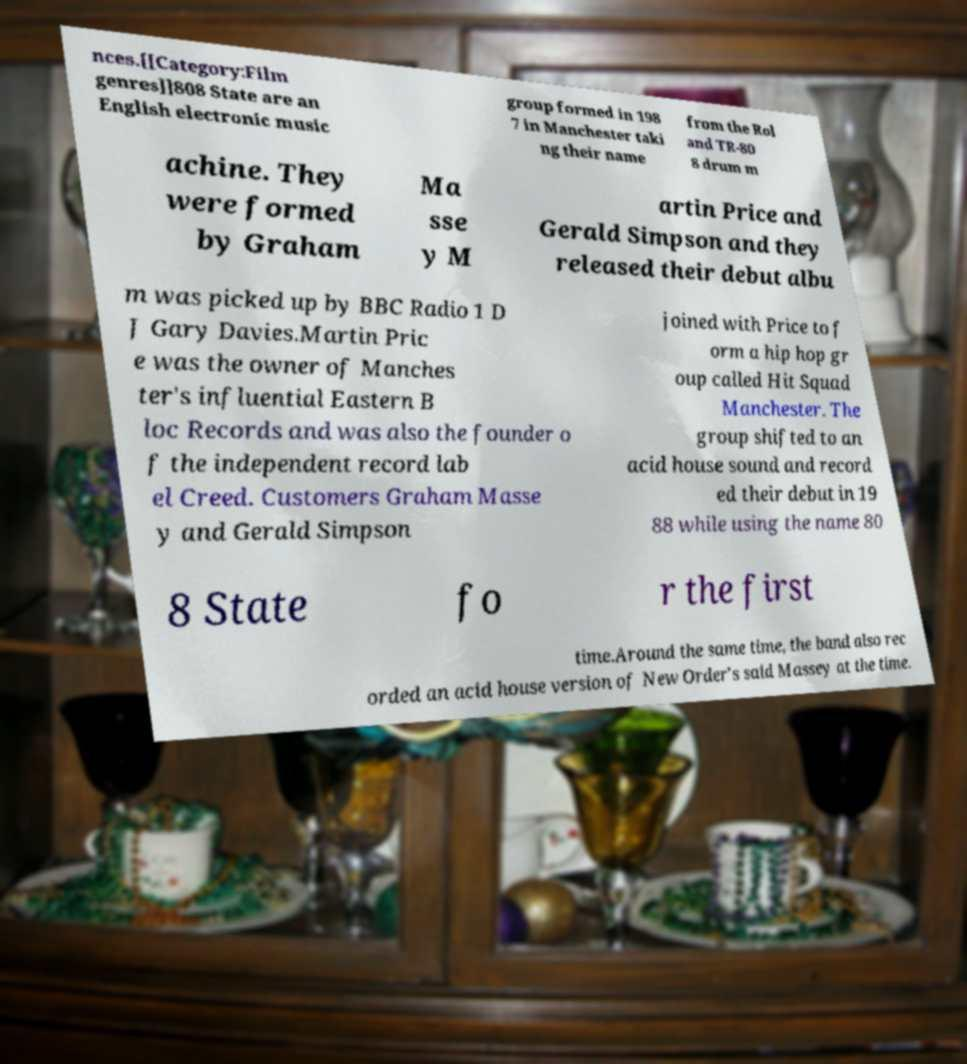I need the written content from this picture converted into text. Can you do that? nces.[[Category:Film genres]]808 State are an English electronic music group formed in 198 7 in Manchester taki ng their name from the Rol and TR-80 8 drum m achine. They were formed by Graham Ma sse y M artin Price and Gerald Simpson and they released their debut albu m was picked up by BBC Radio 1 D J Gary Davies.Martin Pric e was the owner of Manches ter's influential Eastern B loc Records and was also the founder o f the independent record lab el Creed. Customers Graham Masse y and Gerald Simpson joined with Price to f orm a hip hop gr oup called Hit Squad Manchester. The group shifted to an acid house sound and record ed their debut in 19 88 while using the name 80 8 State fo r the first time.Around the same time, the band also rec orded an acid house version of New Order's said Massey at the time. 